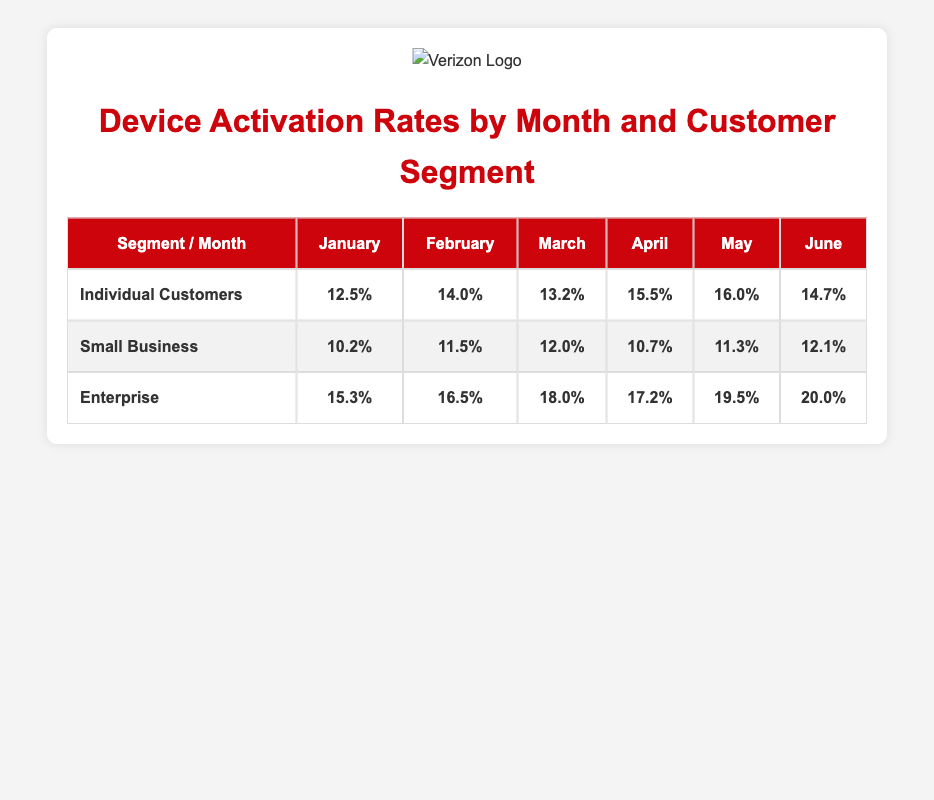What was the activation rate for Enterprise customers in March? In the table, under the "Enterprise" segment and "March" column, the activation rate is listed as 18.0%.
Answer: 18.0% Which month had the highest activation rate for Individual Customers? Looking at the "Individual Customers" row, the highest activation rate appears in May at 16.0%.
Answer: May What is the average activation rate for Small Business customers over the six months? To find the average for the "Small Business" segment, we sum the activation rates (10.2 + 11.5 + 12.0 + 10.7 + 11.3 + 12.1 = 67.8) and divide by 6, which results in 67.8 / 6 = 11.3.
Answer: 11.3 Is the activation rate for Individual Customers consistently increasing month over month? By checking each month's rate for "Individual Customers," we see that the rates are: 12.5, 14.0, 13.2, 15.5, 16.0, and 14.7. It increases in January to February, then decreases in March, increases again in April and May, and then decreases in June. Therefore, it is not consistent.
Answer: No Which segment had the overall highest activation rate across all months combined? First, we sum up the activation rates for each segment: For "Individual Customers," it adds up to 12.5 + 14.0 + 13.2 + 15.5 + 16.0 + 14.7 = 86.9; for "Small Business," it totals 10.2 + 11.5 + 12.0 + 10.7 + 11.3 + 12.1 = 67.8; and for "Enterprise," the total is 15.3 + 16.5 + 18.0 + 17.2 + 19.5 + 20.0 = 106.5. The "Enterprise" segment has the highest total.
Answer: Enterprise 